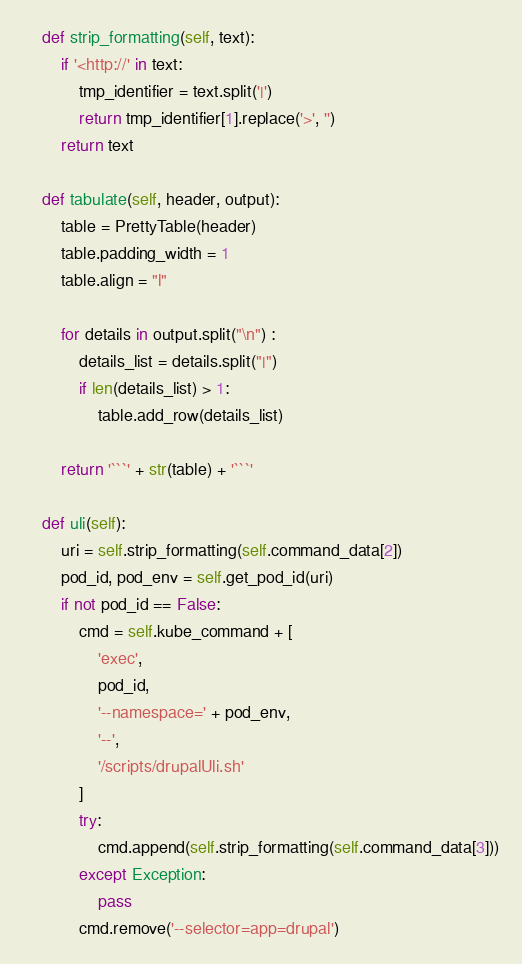<code> <loc_0><loc_0><loc_500><loc_500><_Python_>    def strip_formatting(self, text):
        if '<http://' in text:
            tmp_identifier = text.split('|')
            return tmp_identifier[1].replace('>', '')
        return text

    def tabulate(self, header, output):
        table = PrettyTable(header)
        table.padding_width = 1
        table.align = "l"

        for details in output.split("\n") :
            details_list = details.split("|")
            if len(details_list) > 1:
                table.add_row(details_list)

        return '```' + str(table) + '```'

    def uli(self):
        uri = self.strip_formatting(self.command_data[2])
        pod_id, pod_env = self.get_pod_id(uri)
        if not pod_id == False:
            cmd = self.kube_command + [
                'exec',
                pod_id,
                '--namespace=' + pod_env,
                '--',
                '/scripts/drupalUli.sh'
            ]
            try:
                cmd.append(self.strip_formatting(self.command_data[3]))
            except Exception:
                pass
            cmd.remove('--selector=app=drupal')</code> 